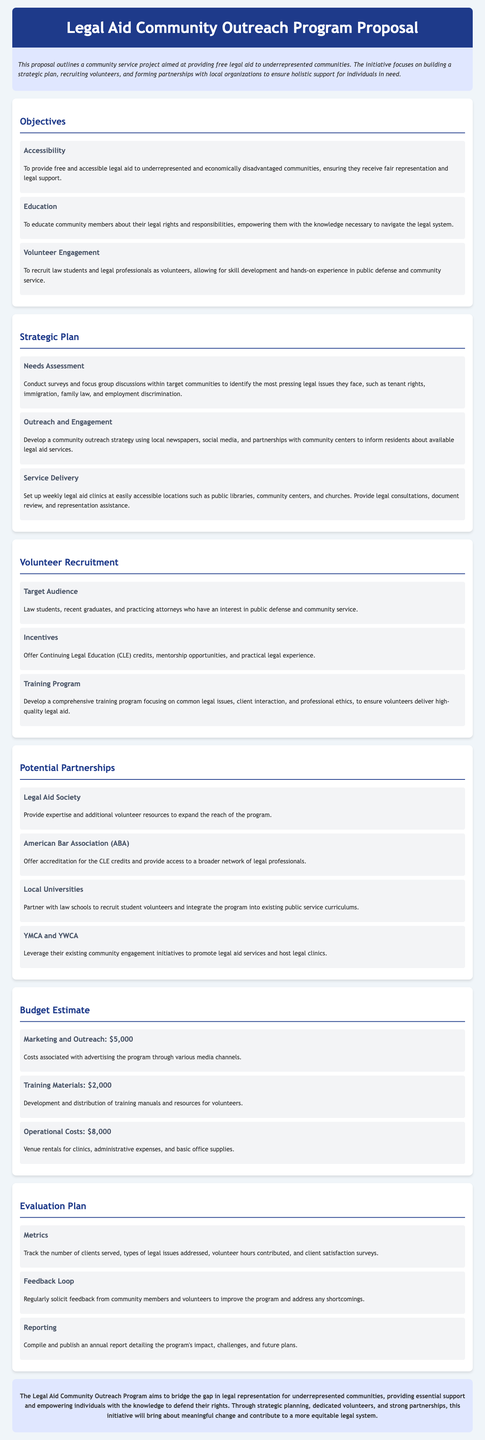what is the main goal of the Legal Aid Community Outreach Program? The main goal is to provide free and accessible legal aid to underrepresented and economically disadvantaged communities.
Answer: free and accessible legal aid how many objectives are listed in the document? The document lists three objectives under the "Objectives" section.
Answer: three which organization aims to provide expertise and additional volunteer resources? The organization mentioned is the Legal Aid Society.
Answer: Legal Aid Society what is the budget for marketing and outreach? The budget for marketing and outreach is specified in the Budget Estimate section.
Answer: $5,000 what kind of credits are offered as incentives for volunteers? The incentives offered for volunteers include Continuing Legal Education credits.
Answer: Continuing Legal Education credits which strategy is used to inform residents about legal aid services? The outreach strategy mentioned includes local newspapers and social media as methods for informing residents.
Answer: local newspapers and social media what document will detail the program's impact and future plans? The document that will detail the program's impact and future plans is the annual report.
Answer: annual report who are the target volunteers for the program? The target audience for volunteer recruitment includes law students, recent graduates, and practicing attorneys.
Answer: law students, recent graduates, and practicing attorneys what is one common legal issue that may be addressed through the program? One common legal issue that may be addressed is tenant rights.
Answer: tenant rights 